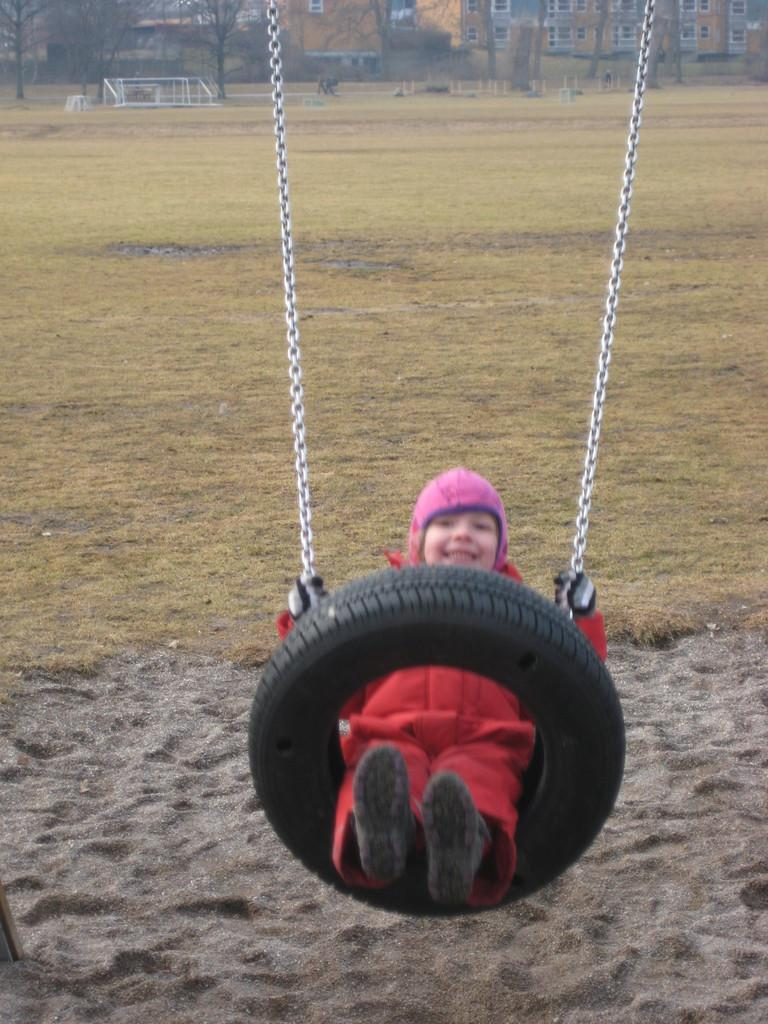What is the kid doing in the image? The kid is swinging in the image. Where is the kid swinging? The swinging is taking place in a ground. What can be seen in the background of the image? Buildings and trees are visible at the top of the image. What is the kid's desire while swinging at the seashore in the image? There is no seashore present in the image; it shows a kid swinging in a ground with buildings and trees in the background. 